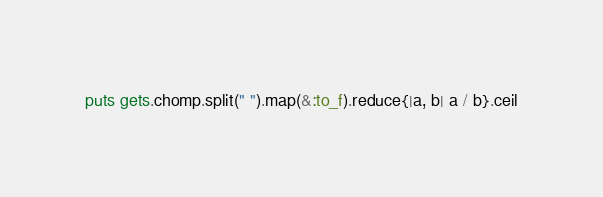<code> <loc_0><loc_0><loc_500><loc_500><_Ruby_>puts gets.chomp.split(" ").map(&:to_f).reduce{|a, b| a / b}.ceil</code> 